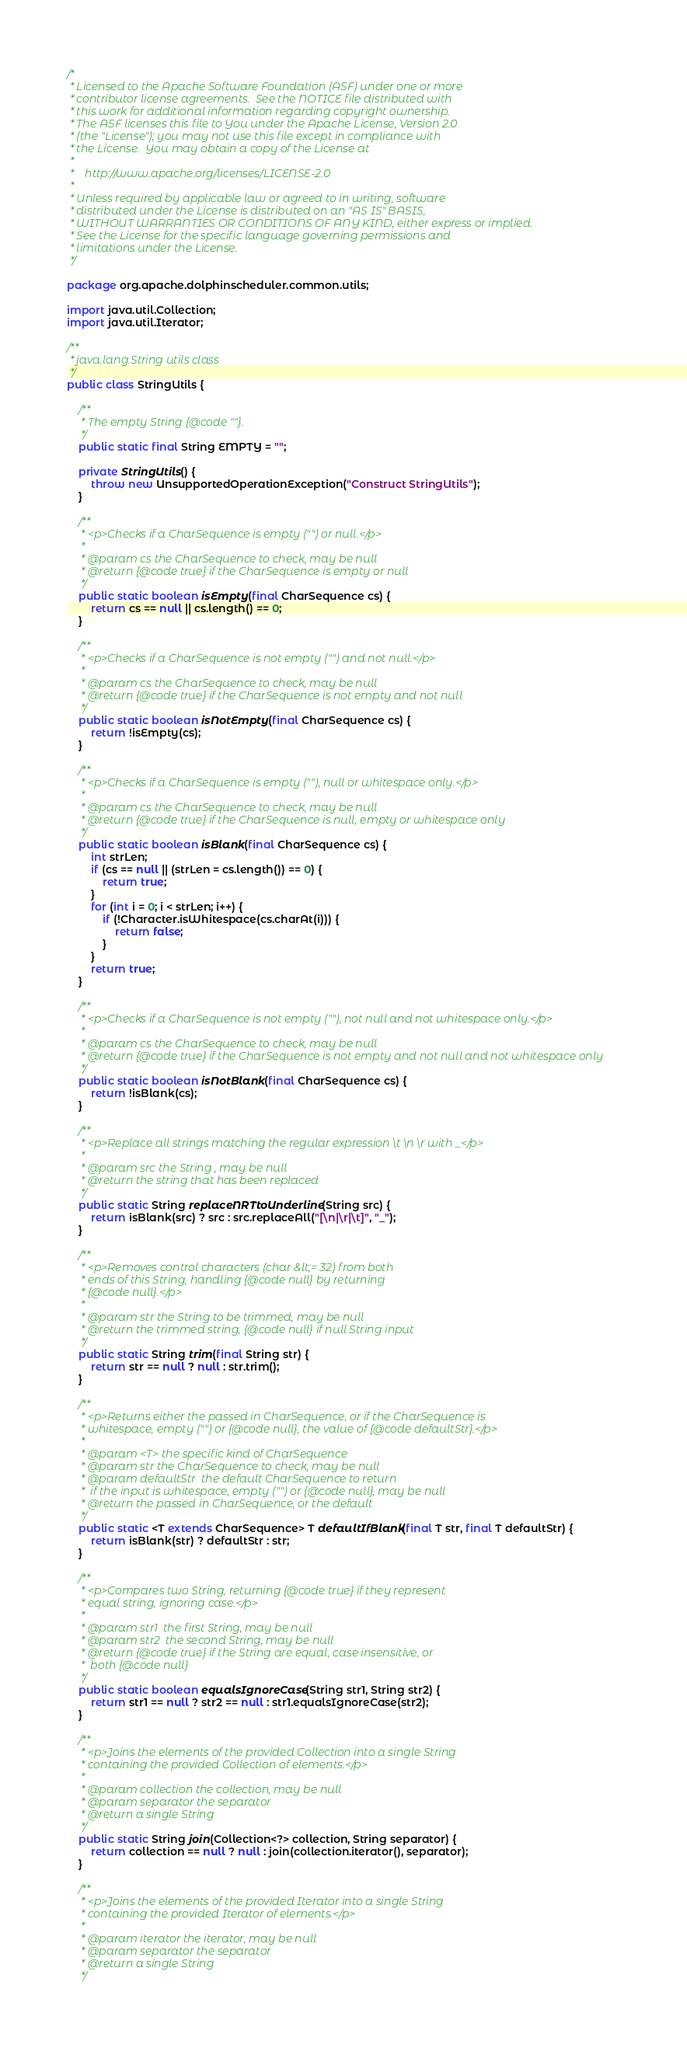<code> <loc_0><loc_0><loc_500><loc_500><_Java_>/*
 * Licensed to the Apache Software Foundation (ASF) under one or more
 * contributor license agreements.  See the NOTICE file distributed with
 * this work for additional information regarding copyright ownership.
 * The ASF licenses this file to You under the Apache License, Version 2.0
 * (the "License"); you may not use this file except in compliance with
 * the License.  You may obtain a copy of the License at
 *
 *    http://www.apache.org/licenses/LICENSE-2.0
 *
 * Unless required by applicable law or agreed to in writing, software
 * distributed under the License is distributed on an "AS IS" BASIS,
 * WITHOUT WARRANTIES OR CONDITIONS OF ANY KIND, either express or implied.
 * See the License for the specific language governing permissions and
 * limitations under the License.
 */

package org.apache.dolphinscheduler.common.utils;

import java.util.Collection;
import java.util.Iterator;

/**
 * java.lang.String utils class
 */
public class StringUtils {

    /**
     * The empty String {@code ""}.
     */
    public static final String EMPTY = "";

    private StringUtils() {
        throw new UnsupportedOperationException("Construct StringUtils");
    }

    /**
     * <p>Checks if a CharSequence is empty ("") or null.</p>
     *
     * @param cs the CharSequence to check, may be null
     * @return {@code true} if the CharSequence is empty or null
     */
    public static boolean isEmpty(final CharSequence cs) {
        return cs == null || cs.length() == 0;
    }

    /**
     * <p>Checks if a CharSequence is not empty ("") and not null.</p>
     *
     * @param cs the CharSequence to check, may be null
     * @return {@code true} if the CharSequence is not empty and not null
     */
    public static boolean isNotEmpty(final CharSequence cs) {
        return !isEmpty(cs);
    }

    /**
     * <p>Checks if a CharSequence is empty (""), null or whitespace only.</p>
     *
     * @param cs the CharSequence to check, may be null
     * @return {@code true} if the CharSequence is null, empty or whitespace only
     */
    public static boolean isBlank(final CharSequence cs) {
        int strLen;
        if (cs == null || (strLen = cs.length()) == 0) {
            return true;
        }
        for (int i = 0; i < strLen; i++) {
            if (!Character.isWhitespace(cs.charAt(i))) {
                return false;
            }
        }
        return true;
    }

    /**
     * <p>Checks if a CharSequence is not empty (""), not null and not whitespace only.</p>
     *
     * @param cs the CharSequence to check, may be null
     * @return {@code true} if the CharSequence is not empty and not null and not whitespace only
     */
    public static boolean isNotBlank(final CharSequence cs) {
        return !isBlank(cs);
    }

    /**
     * <p>Replace all strings matching the regular expression \t \n \r with _</p>
     *
     * @param src the String , may be null
     * @return the string that has been replaced
     */
    public static String replaceNRTtoUnderline(String src) {
        return isBlank(src) ? src : src.replaceAll("[\n|\r|\t]", "_");
    }

    /**
     * <p>Removes control characters (char &lt;= 32) from both
     * ends of this String, handling {@code null} by returning
     * {@code null}.</p>
     *
     * @param str the String to be trimmed, may be null
     * @return the trimmed string, {@code null} if null String input
     */
    public static String trim(final String str) {
        return str == null ? null : str.trim();
    }

    /**
     * <p>Returns either the passed in CharSequence, or if the CharSequence is
     * whitespace, empty ("") or {@code null}, the value of {@code defaultStr}.</p>
     *
     * @param <T> the specific kind of CharSequence
     * @param str the CharSequence to check, may be null
     * @param defaultStr  the default CharSequence to return
     *  if the input is whitespace, empty ("") or {@code null}, may be null
     * @return the passed in CharSequence, or the default
     */
    public static <T extends CharSequence> T defaultIfBlank(final T str, final T defaultStr) {
        return isBlank(str) ? defaultStr : str;
    }

    /**
     * <p>Compares two String, returning {@code true} if they represent
     * equal string, ignoring case.</p>
     *
     * @param str1  the first String, may be null
     * @param str2  the second String, may be null
     * @return {@code true} if the String are equal, case insensitive, or
     *  both {@code null}
     */
    public static boolean equalsIgnoreCase(String str1, String str2) {
        return str1 == null ? str2 == null : str1.equalsIgnoreCase(str2);
    }

    /**
     * <p>Joins the elements of the provided Collection into a single String
     * containing the provided Collection of elements.</p>
     *
     * @param collection the collection, may be null
     * @param separator the separator
     * @return a single String
     */
    public static String join(Collection<?> collection, String separator) {
        return collection == null ? null : join(collection.iterator(), separator);
    }

    /**
     * <p>Joins the elements of the provided Iterator into a single String
     * containing the provided Iterator of elements.</p>
     *
     * @param iterator the iterator, may be null
     * @param separator the separator
     * @return a single String
     */</code> 